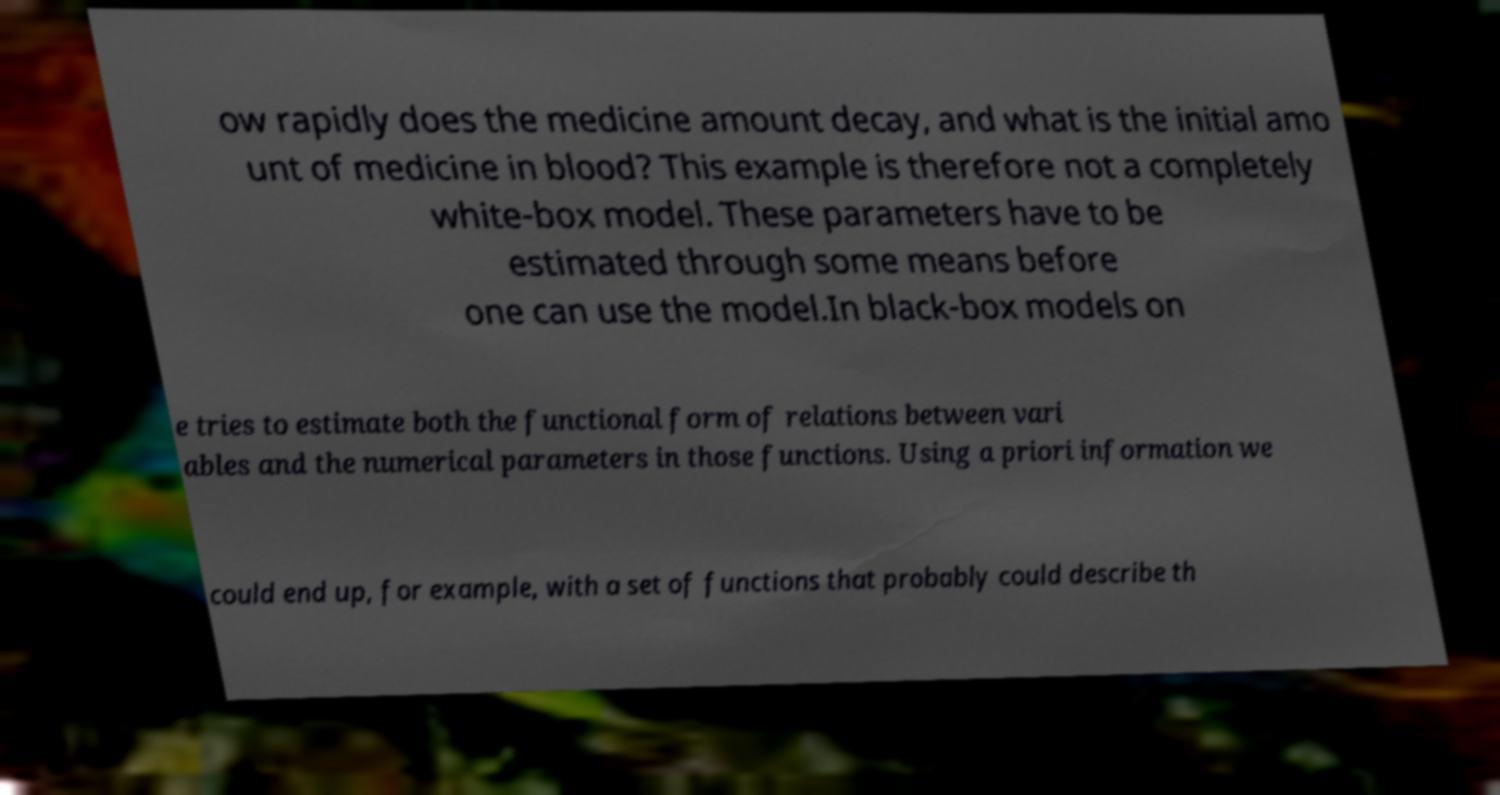Can you read and provide the text displayed in the image?This photo seems to have some interesting text. Can you extract and type it out for me? ow rapidly does the medicine amount decay, and what is the initial amo unt of medicine in blood? This example is therefore not a completely white-box model. These parameters have to be estimated through some means before one can use the model.In black-box models on e tries to estimate both the functional form of relations between vari ables and the numerical parameters in those functions. Using a priori information we could end up, for example, with a set of functions that probably could describe th 